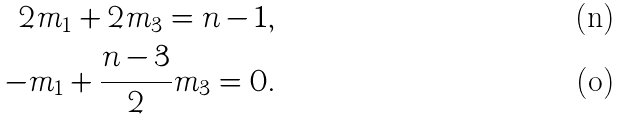Convert formula to latex. <formula><loc_0><loc_0><loc_500><loc_500>2 m _ { 1 } + 2 m _ { 3 } = n - 1 , \\ - m _ { 1 } + \frac { n - 3 } { 2 } m _ { 3 } = 0 .</formula> 